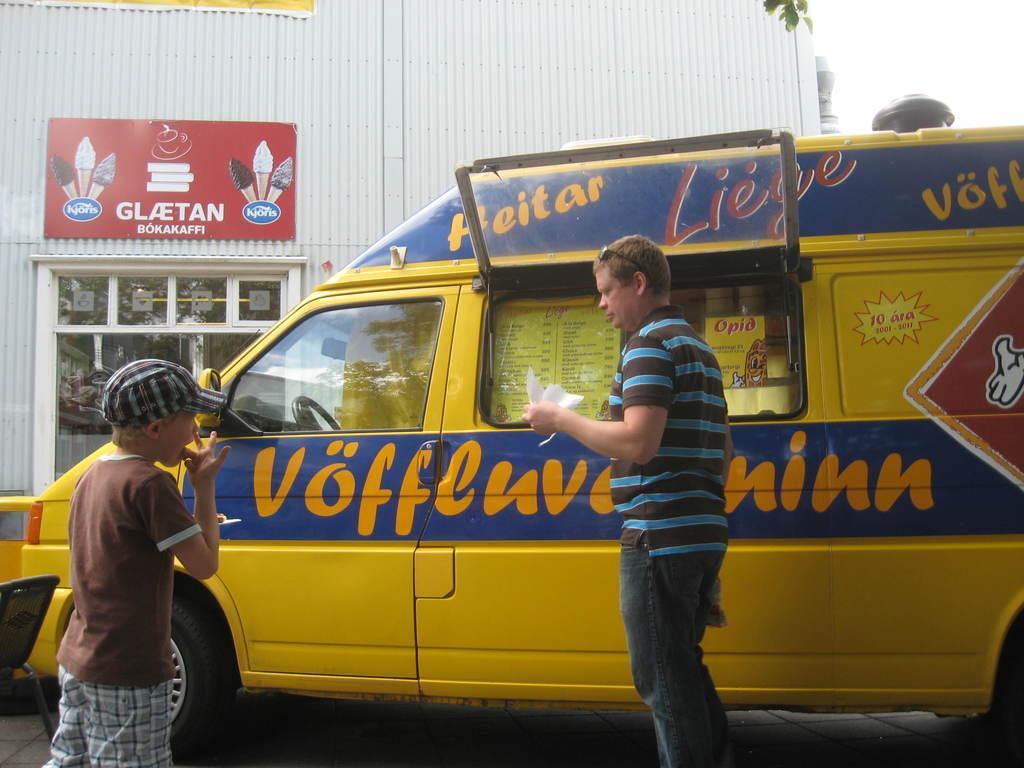Describe this image in one or two sentences. In this image, on the left side, we can see a boy. In the middle of the image, we can see a man holding a paper in his hand. In the background, we can see a vehicle, building, glass door, board with some pictures and text written on it and a sky. 